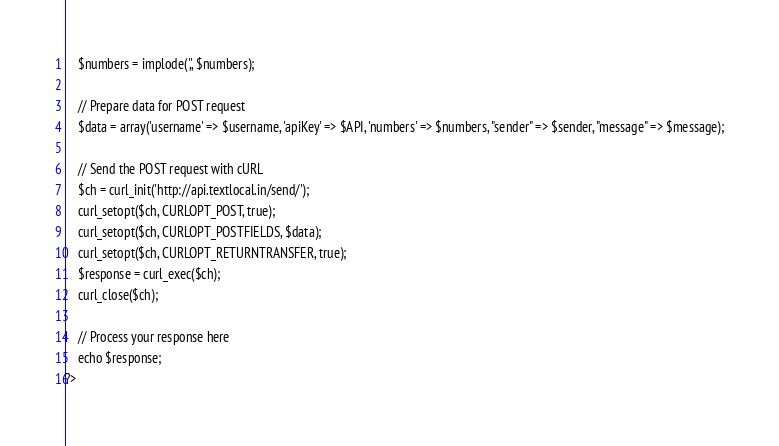<code> <loc_0><loc_0><loc_500><loc_500><_PHP_>	$numbers = implode(',', $numbers);
 
	// Prepare data for POST request
	$data = array('username' => $username, 'apiKey' => $API, 'numbers' => $numbers, "sender" => $sender, "message" => $message);
 
	// Send the POST request with cURL
	$ch = curl_init('http://api.textlocal.in/send/');
	curl_setopt($ch, CURLOPT_POST, true);
	curl_setopt($ch, CURLOPT_POSTFIELDS, $data);
	curl_setopt($ch, CURLOPT_RETURNTRANSFER, true);
	$response = curl_exec($ch);
	curl_close($ch);
	
	// Process your response here
	echo $response;
?></code> 